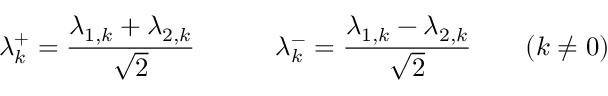Convert formula to latex. <formula><loc_0><loc_0><loc_500><loc_500>\lambda _ { k } ^ { + } = \frac { \lambda _ { 1 , k } + \lambda _ { 2 , k } } { \sqrt { 2 } } \quad \lambda _ { k } ^ { - } = \frac { \lambda _ { 1 , k } - \lambda _ { 2 , k } } { \sqrt { 2 } } \quad ( k \neq 0 )</formula> 